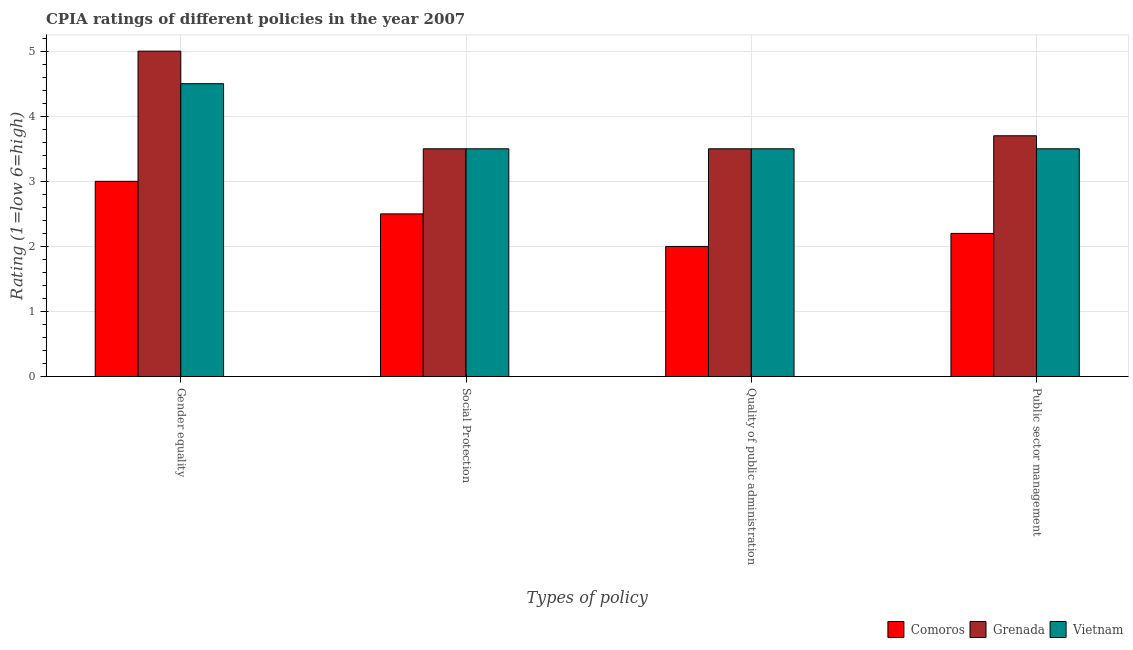How many different coloured bars are there?
Provide a short and direct response. 3. How many groups of bars are there?
Your answer should be compact. 4. How many bars are there on the 2nd tick from the left?
Offer a very short reply. 3. What is the label of the 1st group of bars from the left?
Your answer should be very brief. Gender equality. What is the cpia rating of gender equality in Vietnam?
Offer a terse response. 4.5. Across all countries, what is the maximum cpia rating of quality of public administration?
Your answer should be very brief. 3.5. In which country was the cpia rating of public sector management maximum?
Your answer should be compact. Grenada. In which country was the cpia rating of quality of public administration minimum?
Keep it short and to the point. Comoros. What is the total cpia rating of quality of public administration in the graph?
Provide a short and direct response. 9. What is the difference between the cpia rating of gender equality in Grenada and that in Comoros?
Keep it short and to the point. 2. What is the difference between the cpia rating of social protection in Grenada and the cpia rating of quality of public administration in Vietnam?
Offer a very short reply. 0. What is the average cpia rating of public sector management per country?
Provide a short and direct response. 3.13. What is the difference between the cpia rating of gender equality and cpia rating of social protection in Comoros?
Your response must be concise. 0.5. In how many countries, is the cpia rating of public sector management greater than 2.4 ?
Keep it short and to the point. 2. What is the ratio of the cpia rating of quality of public administration in Grenada to that in Vietnam?
Offer a very short reply. 1. Is the cpia rating of quality of public administration in Grenada less than that in Vietnam?
Ensure brevity in your answer.  No. Is the difference between the cpia rating of public sector management in Grenada and Vietnam greater than the difference between the cpia rating of quality of public administration in Grenada and Vietnam?
Give a very brief answer. Yes. What is the difference between the highest and the second highest cpia rating of public sector management?
Your answer should be very brief. 0.2. What is the difference between the highest and the lowest cpia rating of social protection?
Your answer should be very brief. 1. In how many countries, is the cpia rating of quality of public administration greater than the average cpia rating of quality of public administration taken over all countries?
Your answer should be very brief. 2. Is it the case that in every country, the sum of the cpia rating of gender equality and cpia rating of quality of public administration is greater than the sum of cpia rating of public sector management and cpia rating of social protection?
Offer a very short reply. No. What does the 3rd bar from the left in Gender equality represents?
Keep it short and to the point. Vietnam. What does the 3rd bar from the right in Quality of public administration represents?
Offer a very short reply. Comoros. How many countries are there in the graph?
Offer a terse response. 3. What is the difference between two consecutive major ticks on the Y-axis?
Your answer should be very brief. 1. Does the graph contain any zero values?
Offer a very short reply. No. Where does the legend appear in the graph?
Your answer should be compact. Bottom right. What is the title of the graph?
Your answer should be compact. CPIA ratings of different policies in the year 2007. Does "Korea (Democratic)" appear as one of the legend labels in the graph?
Give a very brief answer. No. What is the label or title of the X-axis?
Give a very brief answer. Types of policy. What is the label or title of the Y-axis?
Ensure brevity in your answer.  Rating (1=low 6=high). What is the Rating (1=low 6=high) in Vietnam in Gender equality?
Your answer should be compact. 4.5. What is the Rating (1=low 6=high) in Comoros in Quality of public administration?
Offer a terse response. 2. What is the Rating (1=low 6=high) of Grenada in Quality of public administration?
Offer a very short reply. 3.5. What is the Rating (1=low 6=high) in Vietnam in Quality of public administration?
Provide a short and direct response. 3.5. What is the Rating (1=low 6=high) of Comoros in Public sector management?
Your response must be concise. 2.2. What is the Rating (1=low 6=high) of Vietnam in Public sector management?
Give a very brief answer. 3.5. Across all Types of policy, what is the maximum Rating (1=low 6=high) in Comoros?
Offer a terse response. 3. Across all Types of policy, what is the maximum Rating (1=low 6=high) of Grenada?
Provide a succinct answer. 5. Across all Types of policy, what is the maximum Rating (1=low 6=high) in Vietnam?
Offer a terse response. 4.5. Across all Types of policy, what is the minimum Rating (1=low 6=high) in Comoros?
Provide a succinct answer. 2. Across all Types of policy, what is the minimum Rating (1=low 6=high) in Vietnam?
Provide a succinct answer. 3.5. What is the total Rating (1=low 6=high) of Grenada in the graph?
Your answer should be very brief. 15.7. What is the total Rating (1=low 6=high) of Vietnam in the graph?
Offer a terse response. 15. What is the difference between the Rating (1=low 6=high) in Grenada in Gender equality and that in Quality of public administration?
Your answer should be very brief. 1.5. What is the difference between the Rating (1=low 6=high) in Vietnam in Gender equality and that in Quality of public administration?
Your answer should be compact. 1. What is the difference between the Rating (1=low 6=high) in Vietnam in Social Protection and that in Quality of public administration?
Provide a short and direct response. 0. What is the difference between the Rating (1=low 6=high) of Vietnam in Social Protection and that in Public sector management?
Give a very brief answer. 0. What is the difference between the Rating (1=low 6=high) in Comoros in Gender equality and the Rating (1=low 6=high) in Grenada in Quality of public administration?
Your answer should be very brief. -0.5. What is the difference between the Rating (1=low 6=high) of Grenada in Gender equality and the Rating (1=low 6=high) of Vietnam in Public sector management?
Provide a short and direct response. 1.5. What is the difference between the Rating (1=low 6=high) in Grenada in Social Protection and the Rating (1=low 6=high) in Vietnam in Quality of public administration?
Ensure brevity in your answer.  0. What is the difference between the Rating (1=low 6=high) in Comoros in Social Protection and the Rating (1=low 6=high) in Vietnam in Public sector management?
Ensure brevity in your answer.  -1. What is the difference between the Rating (1=low 6=high) in Comoros in Quality of public administration and the Rating (1=low 6=high) in Vietnam in Public sector management?
Provide a succinct answer. -1.5. What is the difference between the Rating (1=low 6=high) of Grenada in Quality of public administration and the Rating (1=low 6=high) of Vietnam in Public sector management?
Make the answer very short. 0. What is the average Rating (1=low 6=high) of Comoros per Types of policy?
Your answer should be compact. 2.42. What is the average Rating (1=low 6=high) in Grenada per Types of policy?
Your answer should be compact. 3.92. What is the average Rating (1=low 6=high) in Vietnam per Types of policy?
Your response must be concise. 3.75. What is the difference between the Rating (1=low 6=high) in Comoros and Rating (1=low 6=high) in Grenada in Gender equality?
Offer a very short reply. -2. What is the difference between the Rating (1=low 6=high) in Comoros and Rating (1=low 6=high) in Vietnam in Gender equality?
Your response must be concise. -1.5. What is the difference between the Rating (1=low 6=high) of Grenada and Rating (1=low 6=high) of Vietnam in Gender equality?
Provide a succinct answer. 0.5. What is the difference between the Rating (1=low 6=high) of Comoros and Rating (1=low 6=high) of Vietnam in Social Protection?
Provide a short and direct response. -1. What is the difference between the Rating (1=low 6=high) of Grenada and Rating (1=low 6=high) of Vietnam in Quality of public administration?
Provide a short and direct response. 0. What is the difference between the Rating (1=low 6=high) of Grenada and Rating (1=low 6=high) of Vietnam in Public sector management?
Provide a short and direct response. 0.2. What is the ratio of the Rating (1=low 6=high) of Grenada in Gender equality to that in Social Protection?
Your answer should be very brief. 1.43. What is the ratio of the Rating (1=low 6=high) of Comoros in Gender equality to that in Quality of public administration?
Your answer should be compact. 1.5. What is the ratio of the Rating (1=low 6=high) of Grenada in Gender equality to that in Quality of public administration?
Ensure brevity in your answer.  1.43. What is the ratio of the Rating (1=low 6=high) of Comoros in Gender equality to that in Public sector management?
Offer a terse response. 1.36. What is the ratio of the Rating (1=low 6=high) of Grenada in Gender equality to that in Public sector management?
Offer a terse response. 1.35. What is the ratio of the Rating (1=low 6=high) of Vietnam in Gender equality to that in Public sector management?
Your response must be concise. 1.29. What is the ratio of the Rating (1=low 6=high) in Grenada in Social Protection to that in Quality of public administration?
Your answer should be compact. 1. What is the ratio of the Rating (1=low 6=high) in Vietnam in Social Protection to that in Quality of public administration?
Offer a very short reply. 1. What is the ratio of the Rating (1=low 6=high) in Comoros in Social Protection to that in Public sector management?
Your answer should be compact. 1.14. What is the ratio of the Rating (1=low 6=high) in Grenada in Social Protection to that in Public sector management?
Provide a short and direct response. 0.95. What is the ratio of the Rating (1=low 6=high) in Vietnam in Social Protection to that in Public sector management?
Ensure brevity in your answer.  1. What is the ratio of the Rating (1=low 6=high) in Comoros in Quality of public administration to that in Public sector management?
Make the answer very short. 0.91. What is the ratio of the Rating (1=low 6=high) in Grenada in Quality of public administration to that in Public sector management?
Your answer should be very brief. 0.95. What is the difference between the highest and the lowest Rating (1=low 6=high) in Vietnam?
Provide a short and direct response. 1. 